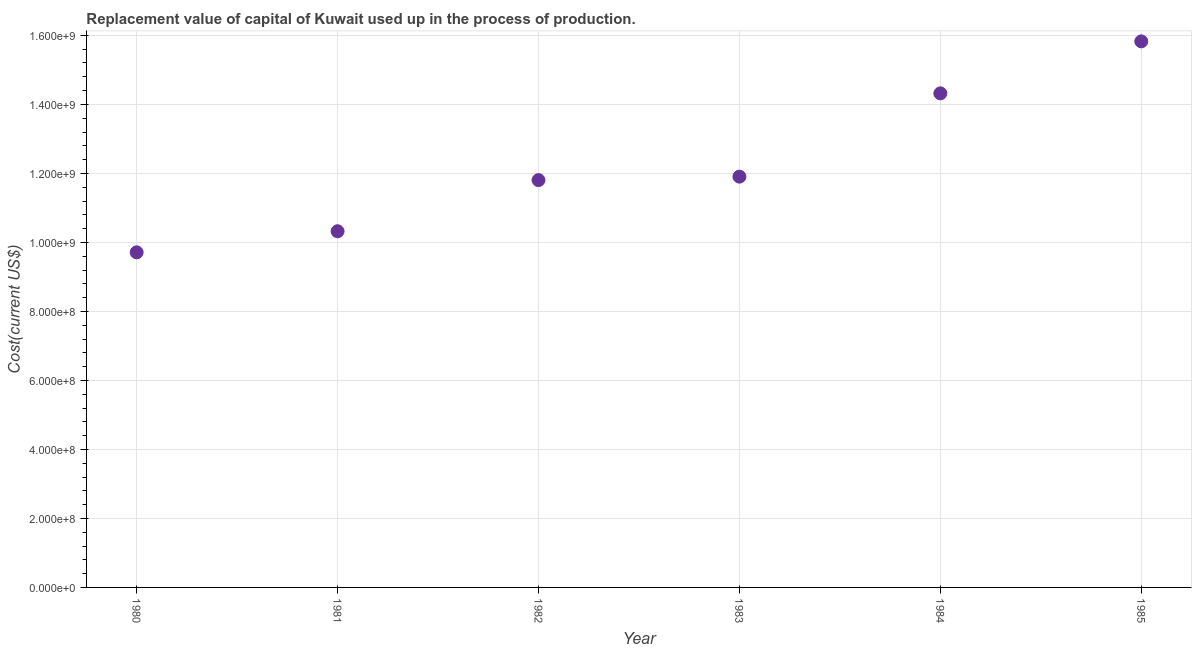What is the consumption of fixed capital in 1985?
Your answer should be compact. 1.58e+09. Across all years, what is the maximum consumption of fixed capital?
Your answer should be very brief. 1.58e+09. Across all years, what is the minimum consumption of fixed capital?
Your answer should be compact. 9.71e+08. In which year was the consumption of fixed capital minimum?
Provide a succinct answer. 1980. What is the sum of the consumption of fixed capital?
Offer a terse response. 7.39e+09. What is the difference between the consumption of fixed capital in 1983 and 1985?
Offer a very short reply. -3.92e+08. What is the average consumption of fixed capital per year?
Make the answer very short. 1.23e+09. What is the median consumption of fixed capital?
Your answer should be very brief. 1.19e+09. Do a majority of the years between 1985 and 1981 (inclusive) have consumption of fixed capital greater than 1320000000 US$?
Offer a terse response. Yes. What is the ratio of the consumption of fixed capital in 1982 to that in 1983?
Your answer should be very brief. 0.99. Is the consumption of fixed capital in 1982 less than that in 1984?
Your answer should be very brief. Yes. What is the difference between the highest and the second highest consumption of fixed capital?
Your response must be concise. 1.51e+08. What is the difference between the highest and the lowest consumption of fixed capital?
Provide a short and direct response. 6.11e+08. In how many years, is the consumption of fixed capital greater than the average consumption of fixed capital taken over all years?
Give a very brief answer. 2. How many dotlines are there?
Provide a succinct answer. 1. What is the difference between two consecutive major ticks on the Y-axis?
Offer a terse response. 2.00e+08. Does the graph contain grids?
Your answer should be compact. Yes. What is the title of the graph?
Your answer should be compact. Replacement value of capital of Kuwait used up in the process of production. What is the label or title of the Y-axis?
Your response must be concise. Cost(current US$). What is the Cost(current US$) in 1980?
Make the answer very short. 9.71e+08. What is the Cost(current US$) in 1981?
Your answer should be compact. 1.03e+09. What is the Cost(current US$) in 1982?
Give a very brief answer. 1.18e+09. What is the Cost(current US$) in 1983?
Make the answer very short. 1.19e+09. What is the Cost(current US$) in 1984?
Your answer should be very brief. 1.43e+09. What is the Cost(current US$) in 1985?
Ensure brevity in your answer.  1.58e+09. What is the difference between the Cost(current US$) in 1980 and 1981?
Give a very brief answer. -6.11e+07. What is the difference between the Cost(current US$) in 1980 and 1982?
Give a very brief answer. -2.09e+08. What is the difference between the Cost(current US$) in 1980 and 1983?
Give a very brief answer. -2.19e+08. What is the difference between the Cost(current US$) in 1980 and 1984?
Offer a very short reply. -4.61e+08. What is the difference between the Cost(current US$) in 1980 and 1985?
Make the answer very short. -6.11e+08. What is the difference between the Cost(current US$) in 1981 and 1982?
Provide a short and direct response. -1.48e+08. What is the difference between the Cost(current US$) in 1981 and 1983?
Ensure brevity in your answer.  -1.58e+08. What is the difference between the Cost(current US$) in 1981 and 1984?
Give a very brief answer. -4.00e+08. What is the difference between the Cost(current US$) in 1981 and 1985?
Your answer should be very brief. -5.50e+08. What is the difference between the Cost(current US$) in 1982 and 1983?
Give a very brief answer. -9.98e+06. What is the difference between the Cost(current US$) in 1982 and 1984?
Offer a terse response. -2.51e+08. What is the difference between the Cost(current US$) in 1982 and 1985?
Provide a succinct answer. -4.02e+08. What is the difference between the Cost(current US$) in 1983 and 1984?
Your response must be concise. -2.41e+08. What is the difference between the Cost(current US$) in 1983 and 1985?
Ensure brevity in your answer.  -3.92e+08. What is the difference between the Cost(current US$) in 1984 and 1985?
Your answer should be compact. -1.51e+08. What is the ratio of the Cost(current US$) in 1980 to that in 1981?
Offer a very short reply. 0.94. What is the ratio of the Cost(current US$) in 1980 to that in 1982?
Give a very brief answer. 0.82. What is the ratio of the Cost(current US$) in 1980 to that in 1983?
Offer a very short reply. 0.82. What is the ratio of the Cost(current US$) in 1980 to that in 1984?
Your answer should be very brief. 0.68. What is the ratio of the Cost(current US$) in 1980 to that in 1985?
Offer a terse response. 0.61. What is the ratio of the Cost(current US$) in 1981 to that in 1982?
Ensure brevity in your answer.  0.87. What is the ratio of the Cost(current US$) in 1981 to that in 1983?
Provide a short and direct response. 0.87. What is the ratio of the Cost(current US$) in 1981 to that in 1984?
Offer a terse response. 0.72. What is the ratio of the Cost(current US$) in 1981 to that in 1985?
Keep it short and to the point. 0.65. What is the ratio of the Cost(current US$) in 1982 to that in 1984?
Provide a short and direct response. 0.82. What is the ratio of the Cost(current US$) in 1982 to that in 1985?
Make the answer very short. 0.75. What is the ratio of the Cost(current US$) in 1983 to that in 1984?
Provide a short and direct response. 0.83. What is the ratio of the Cost(current US$) in 1983 to that in 1985?
Give a very brief answer. 0.75. What is the ratio of the Cost(current US$) in 1984 to that in 1985?
Provide a short and direct response. 0.91. 